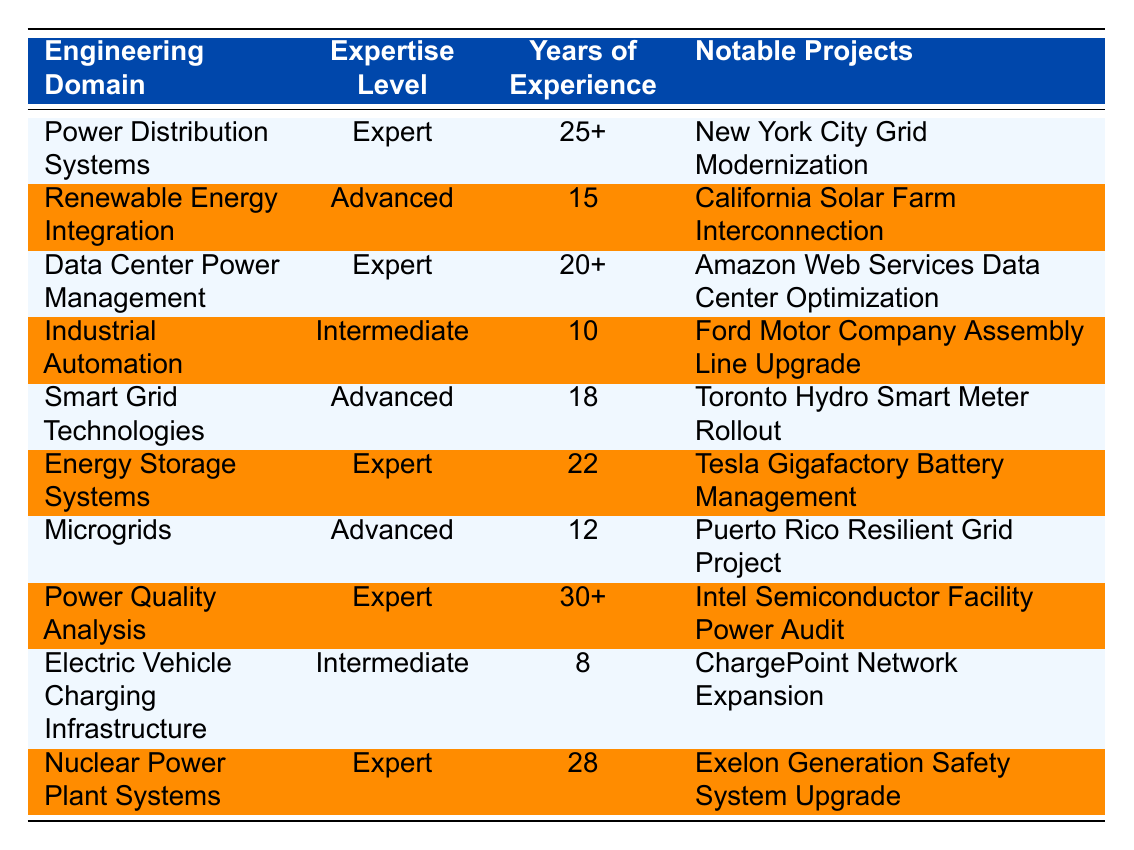What is the expertise level for Power Distribution Systems? The table indicates that the expertise level for Power Distribution Systems is "Expert." This can be directly found in the second column of the first row.
Answer: Expert Which engineering domain has the most years of experience listed? By scanning the Years of Experience column, "Power Quality Analysis" has 30+ years, which is the highest compared to other domains.
Answer: Power Quality Analysis How many engineering domains have an expertise level of Advanced? The table lists three domains with an Advanced expertise level: Renewable Energy Integration, Smart Grid Technologies, and Microgrids. By counting the rows with "Advanced" in the expertise column, the answer is three.
Answer: 3 Is there a domain with less than 10 years of experience? Yes, "Electric Vehicle Charging Infrastructure" has 8 years of experience. This is confirmed by checking the Years of Experience column for values less than 10.
Answer: Yes What is the difference in years of experience between the most experienced domain and the least experienced domain? The most experienced domain is "Power Quality Analysis" with 30+ years, and the least experienced is "Electric Vehicle Charging Infrastructure" with 8 years. The difference is 30 - 8 = 22 years.
Answer: 22 years Which notable project corresponds to Energy Storage Systems? According to the table, the notable project for Energy Storage Systems is "Tesla Gigafactory Battery Management." This is found in the last row under Notable Projects.
Answer: Tesla Gigafactory Battery Management Are there any domains where the expertise level is Intermediate? Yes, there are two domains with Intermediate expertise: Industrial Automation and Electric Vehicle Charging Infrastructure. This can be determined by scanning the expertise level column for "Intermediate."
Answer: Yes Which engineering domain has the same level of expertise as Microgrids? Microgrids has an Advanced expertise level. The other domain with the same level is Renewable Energy Integration and Smart Grid Technologies. This is confirmed by cross-referencing the expertise level column.
Answer: Renewable Energy Integration, Smart Grid Technologies What are the notable projects for domains that are classified as Expert? The notable projects for Expert domains are: "New York City Grid Modernization," "Amazon Web Services Data Center Optimization," "Tesla Gigafactory Battery Management," "Power Quality Analysis," and "Exelon Generation Safety System Upgrade." This is derived by filtering the table for rows with an "Expert" expertise level.
Answer: New York City Grid Modernization, Amazon Web Services Data Center Optimization, Tesla Gigafactory Battery Management, Intel Semiconductor Facility Power Audit, Exelon Generation Safety System Upgrade 